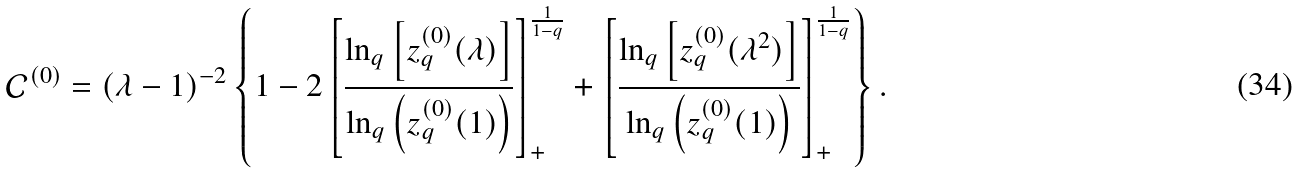Convert formula to latex. <formula><loc_0><loc_0><loc_500><loc_500>\mathcal { C } ^ { ( 0 ) } = ( \lambda - 1 ) ^ { - 2 } \left \{ 1 - 2 \left [ \frac { \ln _ { q } \left [ z _ { q } ^ { ( 0 ) } ( \lambda ) \right ] } { \ln _ { q } \left ( z _ { q } ^ { ( 0 ) } ( 1 ) \right ) } \right ] _ { + } ^ { \frac { 1 } { 1 - q } } + \left [ \frac { \ln _ { q } \left [ z _ { q } ^ { ( 0 ) } ( \lambda ^ { 2 } ) \right ] } { \ln _ { q } \left ( z _ { q } ^ { ( 0 ) } ( 1 ) \right ) } \right ] _ { + } ^ { \frac { 1 } { 1 - q } } \right \} .</formula> 